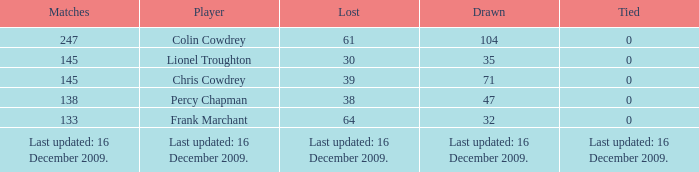Explain the lost having a tie at 0 and 47 drawn games. 38.0. 